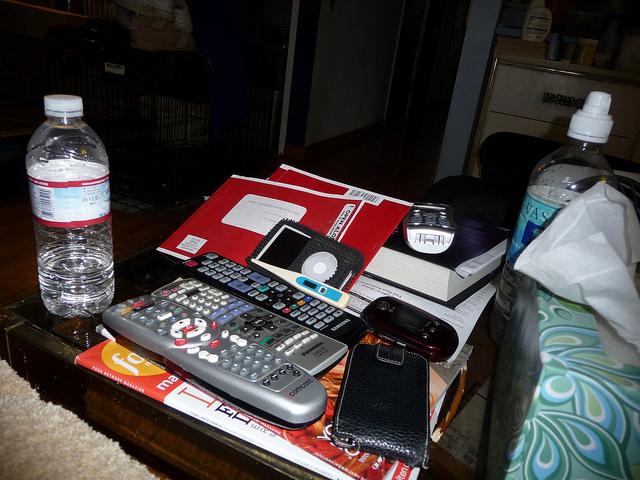What is in the red envelopes?
Quick response, please. Movies. What is next to the bottle?
Quick response, please. Remotes. Is the table cluttered?
Short answer required. Yes. Is this a soft drink?
Be succinct. No. Where did all of these items come from?
Keep it brief. Living room. How much water is inside the bottle?
Give a very brief answer. 1/4. What channel is this remote changing?
Keep it brief. 4. Is the water bottle full?
Write a very short answer. No. 